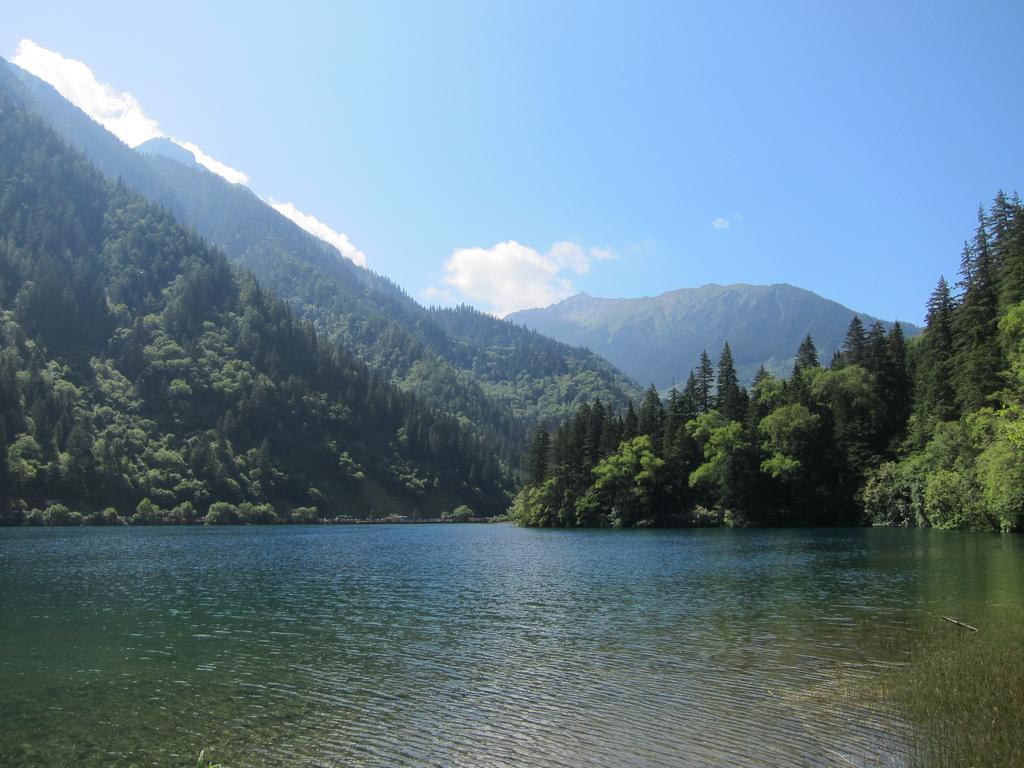In one or two sentences, can you explain what this image depicts? At the bottom we can see water. In the background there are trees,mountains and clouds in the sky. 